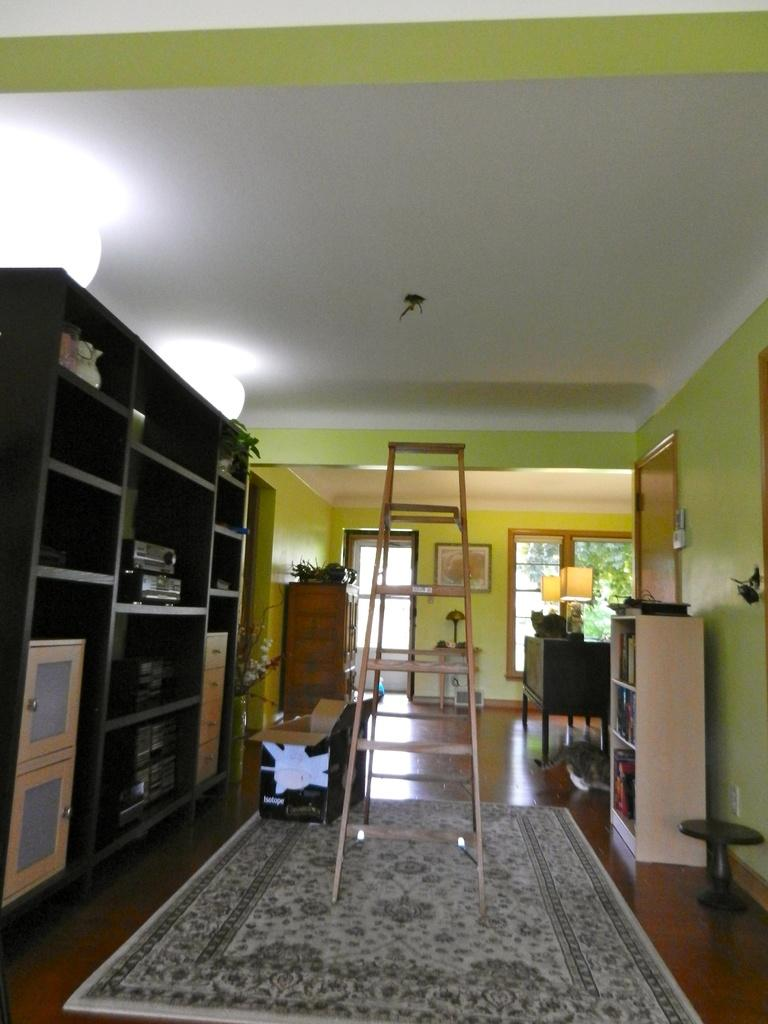What is located on the left side of the image? There are lights on the left side of the image. What can be seen in the middle of the image? There is a ladder in the middle of the image. What is at the back side of the image? There is a door at the back side of the image. How many horses are visible in the image? There are no horses present in the image. Is there a mountain visible in the image? There is no mountain present in the image. 